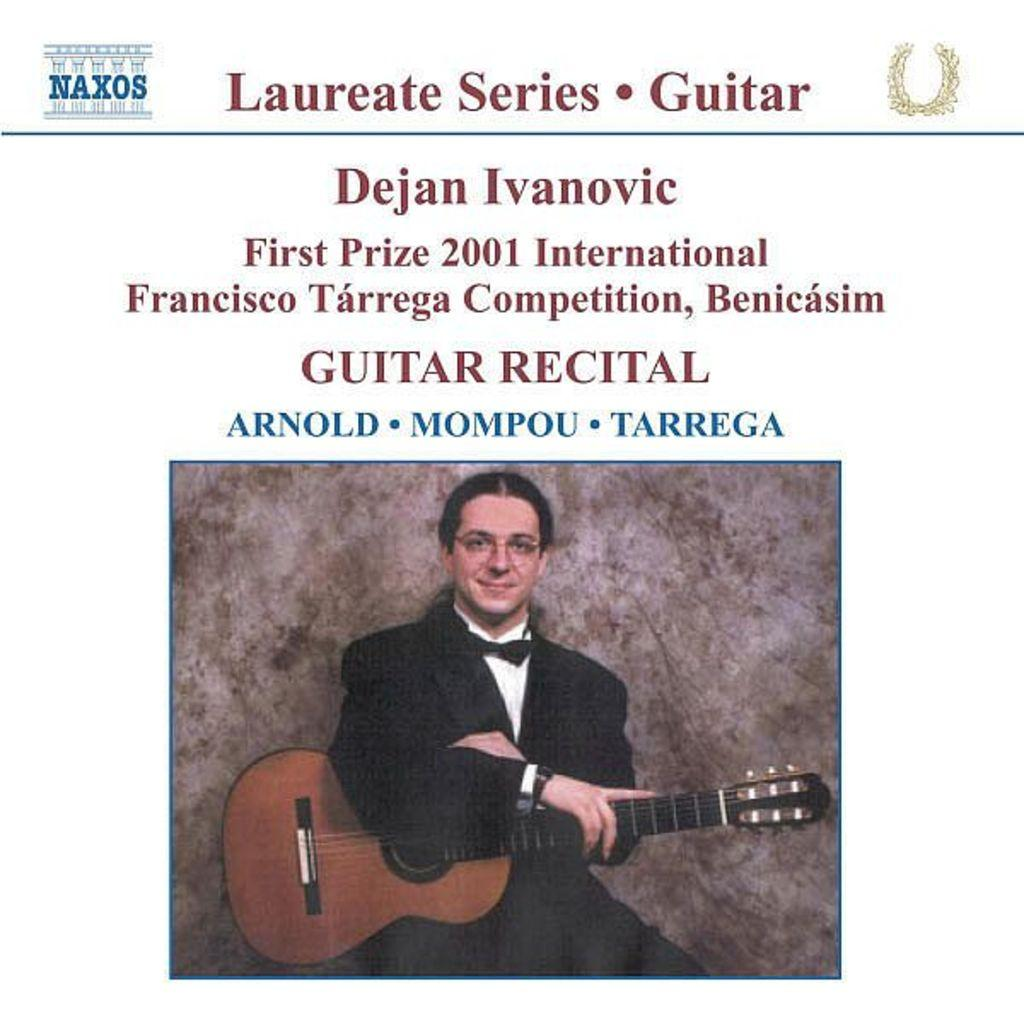Who or what is the main subject of the image? There is a person in the image. What is the person holding in the image? The person is holding a guitar. Can you describe the person's attire in the image? The person is wearing a black suit. What can be seen written on the guitar? The guitar has "Laureate Series" written on it. What is the person's opinion about the existence of bite-sized opinions in the image? There is no mention of opinions, bite-sized or otherwise, in the image. The image only features a person holding a guitar with "Laureate Series" written on it. 